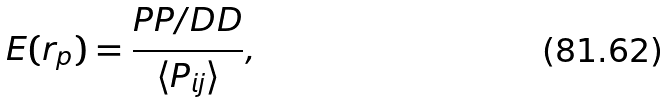Convert formula to latex. <formula><loc_0><loc_0><loc_500><loc_500>E ( r _ { p } ) = \frac { P P / D D } { \langle P _ { i j } \rangle } ,</formula> 